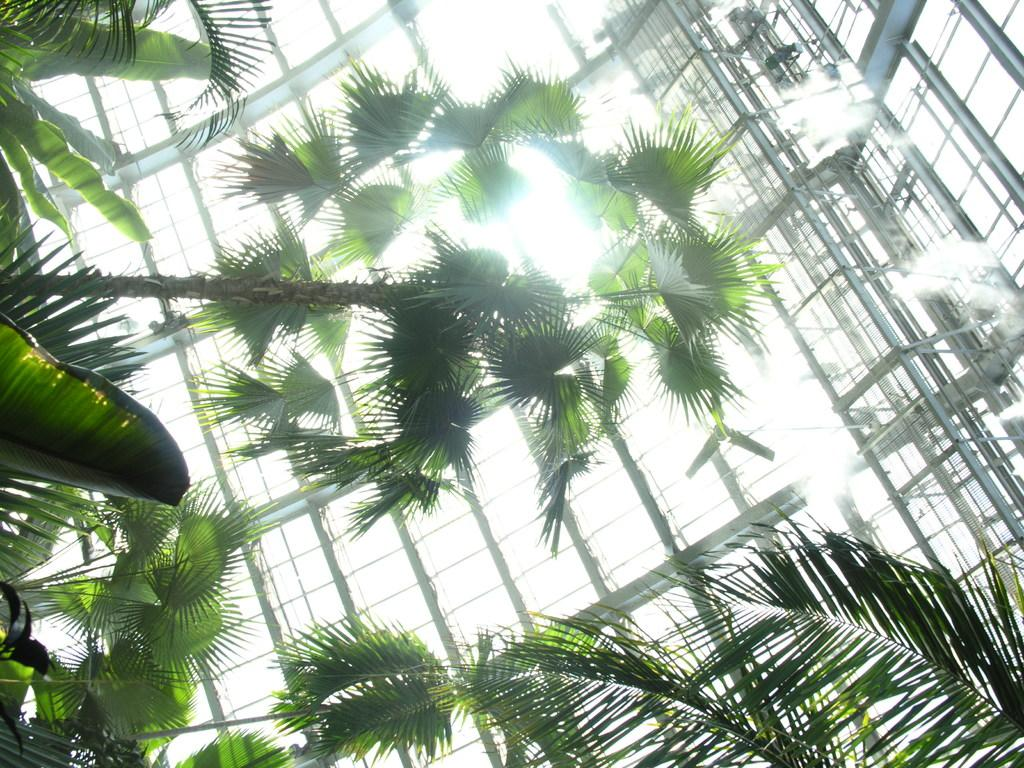What type of trees are present in the image? There are palm trees in the image. What can be seen in the background of the image? There is a ceiling visible in the background of the image. What material are the frames made of in the image? The frames in the image are made of iron. How is sunlight entering the space in the image? Sunshine is falling inside from the ceiling in the image. Are there any balloons visible on the ground in the image? There are no balloons present in the image, and the ground is not visible. Can you see any fangs on the palm trees in the image? There are no fangs present on the palm trees in the image; they are simply trees with leaves and trunks. 